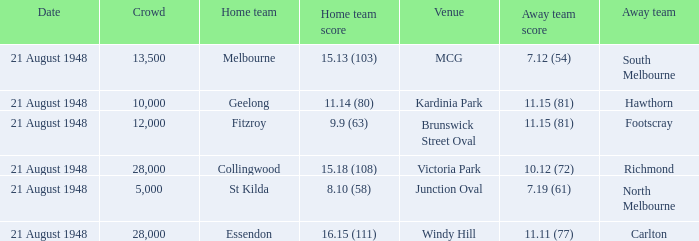When the Home team score was 15.18 (108), what's the lowest Crowd turnout? 28000.0. 